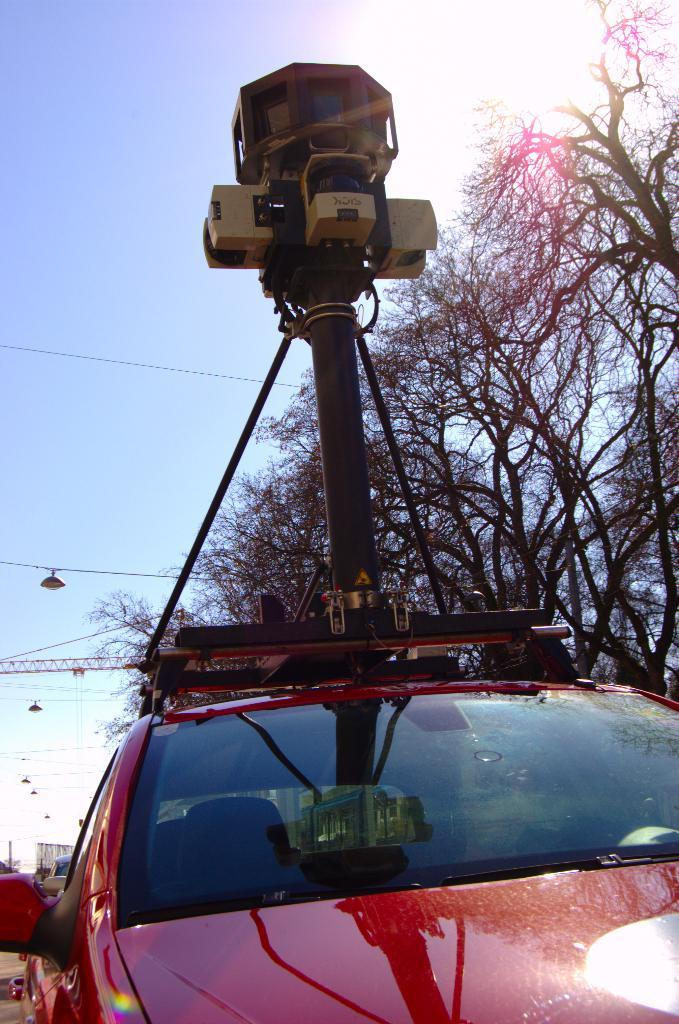What is the main subject of the image? The main subject of the image is a car on the road. What is attached to the car in the image? There is a camera on top of the car in the image. What can be seen in the background of the image? There are trees and the sky visible in the background of the image. What type of cream is being used to create a rhythm in the image? There is no cream or rhythm present in the image; it features a car with a camera on top of it, trees in the background, and the sky visible. 